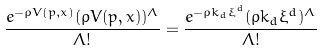<formula> <loc_0><loc_0><loc_500><loc_500>\frac { e ^ { - \rho V ( p , x ) } ( \rho V ( p , x ) ) ^ { \Lambda } } { \Lambda ! } = \frac { e ^ { - \rho k _ { d } \xi ^ { d } } ( \rho k _ { d } \xi ^ { d } ) ^ { \Lambda } } { \Lambda ! }</formula> 